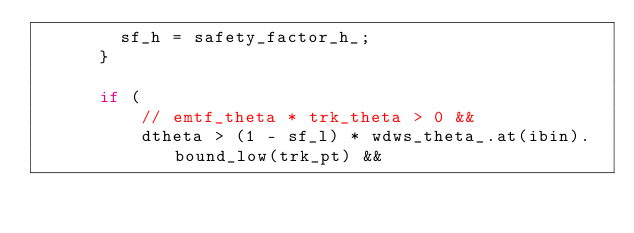Convert code to text. <code><loc_0><loc_0><loc_500><loc_500><_C++_>        sf_h = safety_factor_h_;
      }

      if (
          // emtf_theta * trk_theta > 0 &&
          dtheta > (1 - sf_l) * wdws_theta_.at(ibin).bound_low(trk_pt) &&</code> 